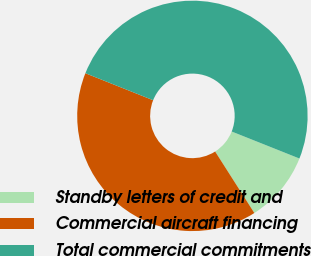Convert chart. <chart><loc_0><loc_0><loc_500><loc_500><pie_chart><fcel>Standby letters of credit and<fcel>Commercial aircraft financing<fcel>Total commercial commitments<nl><fcel>9.93%<fcel>40.07%<fcel>50.0%<nl></chart> 